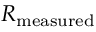<formula> <loc_0><loc_0><loc_500><loc_500>R _ { m e a s u r e d }</formula> 